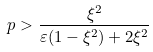<formula> <loc_0><loc_0><loc_500><loc_500>p > \frac { \xi ^ { 2 } } { \varepsilon ( 1 - \xi ^ { 2 } ) + 2 \xi ^ { 2 } }</formula> 